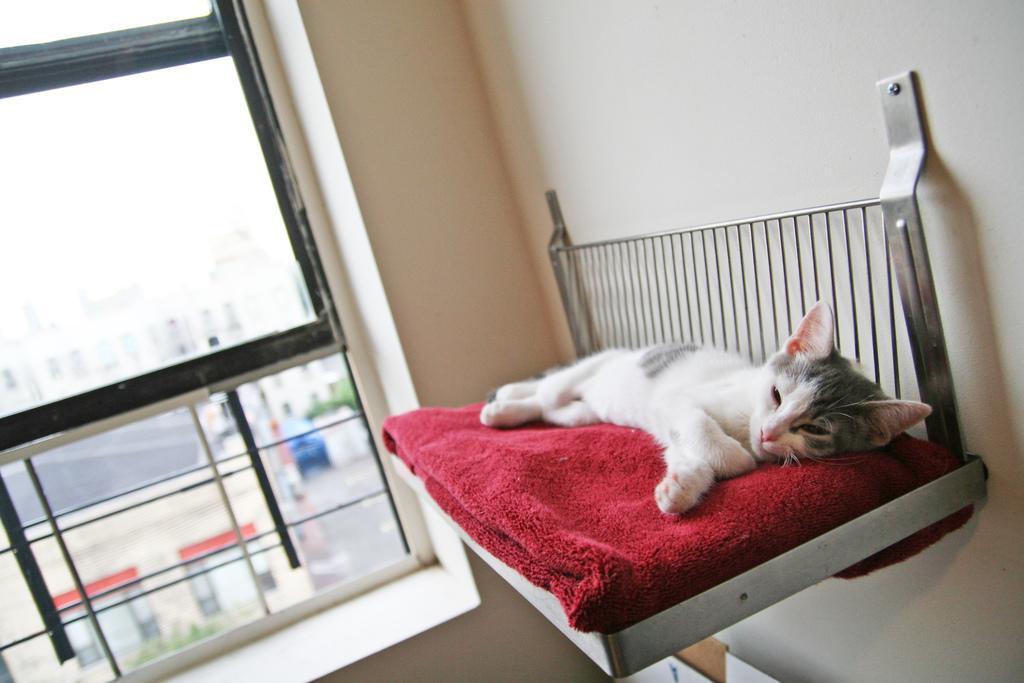How would you summarize this image in a sentence or two? As we can see in the image, there is a house and a cat sleeping on red color cloth. 